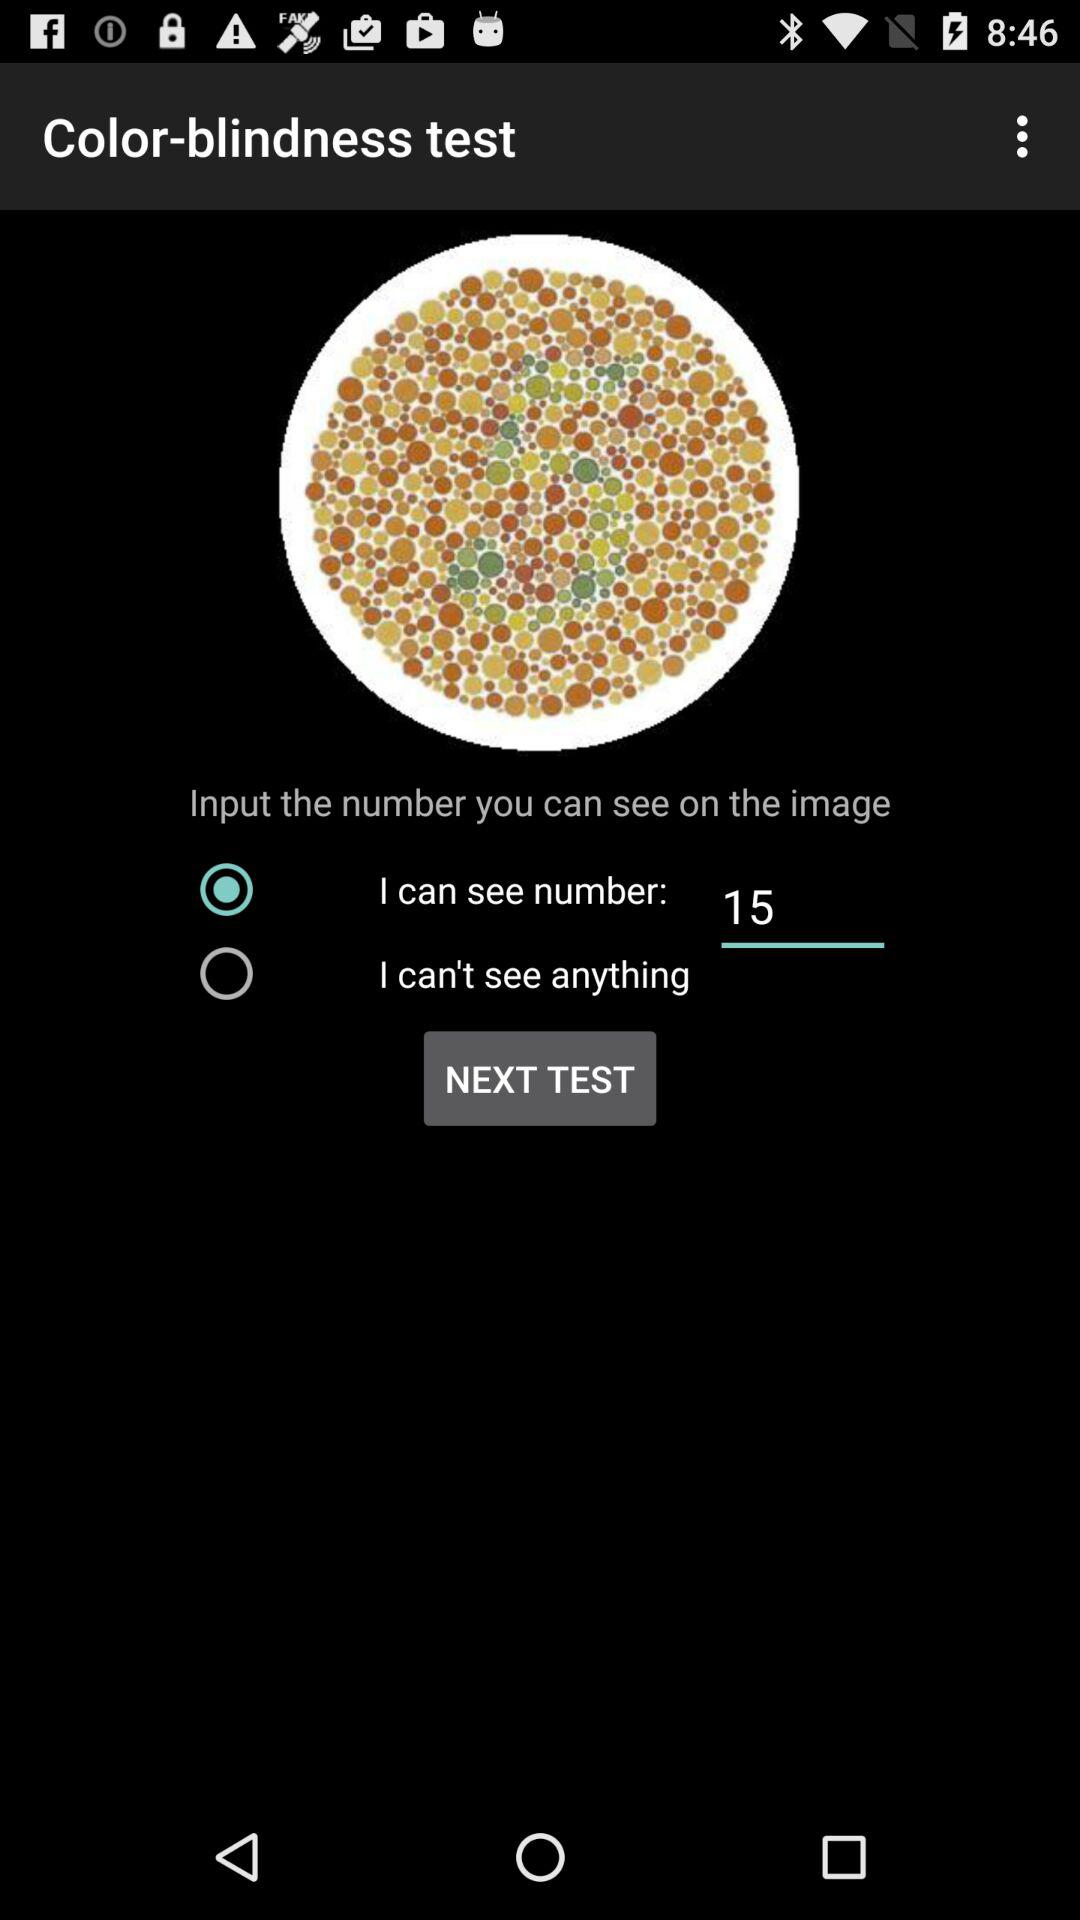Which option is selected? The selected option is "I can see number: 15". 